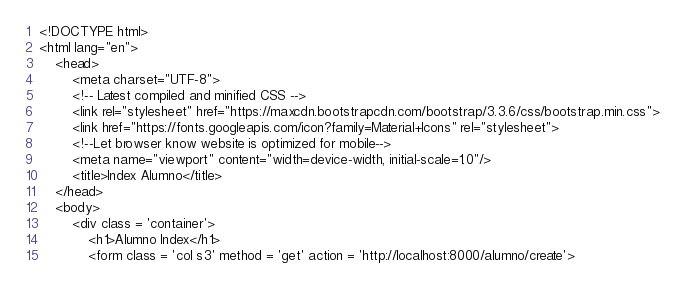Convert code to text. <code><loc_0><loc_0><loc_500><loc_500><_PHP_><!DOCTYPE html>
<html lang="en">
    <head>
        <meta charset="UTF-8">
        <!-- Latest compiled and minified CSS -->
        <link rel="stylesheet" href="https://maxcdn.bootstrapcdn.com/bootstrap/3.3.6/css/bootstrap.min.css">
        <link href="https://fonts.googleapis.com/icon?family=Material+Icons" rel="stylesheet">
        <!--Let browser know website is optimized for mobile-->
        <meta name="viewport" content="width=device-width, initial-scale=1.0"/>
        <title>Index Alumno</title>
    </head>
    <body>
        <div class = 'container'>
            <h1>Alumno Index</h1>
            <form class = 'col s3' method = 'get' action = 'http://localhost:8000/alumno/create'></code> 